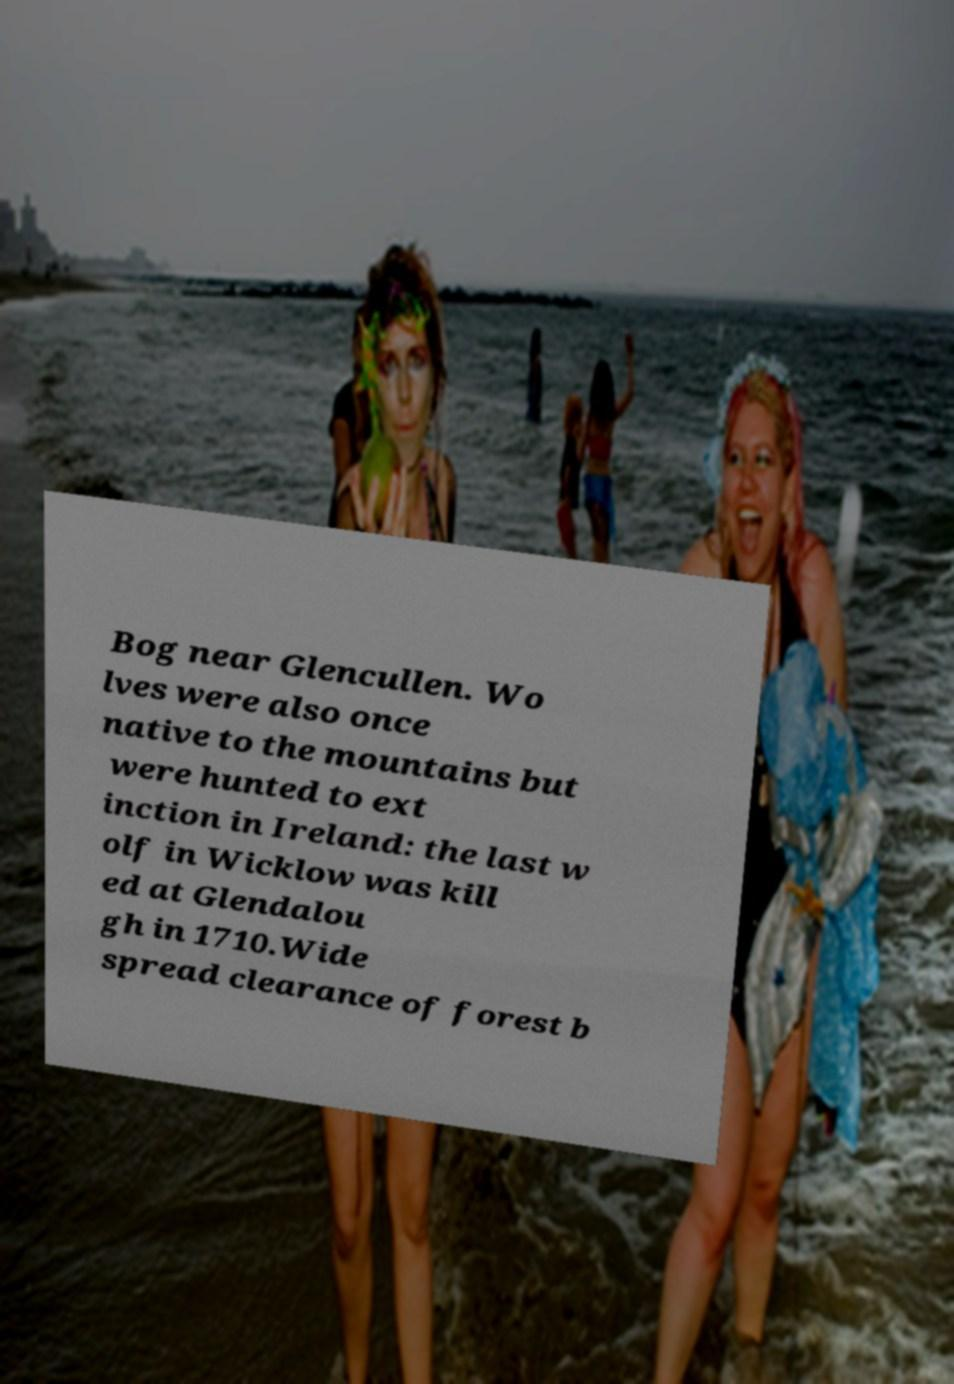There's text embedded in this image that I need extracted. Can you transcribe it verbatim? Bog near Glencullen. Wo lves were also once native to the mountains but were hunted to ext inction in Ireland: the last w olf in Wicklow was kill ed at Glendalou gh in 1710.Wide spread clearance of forest b 